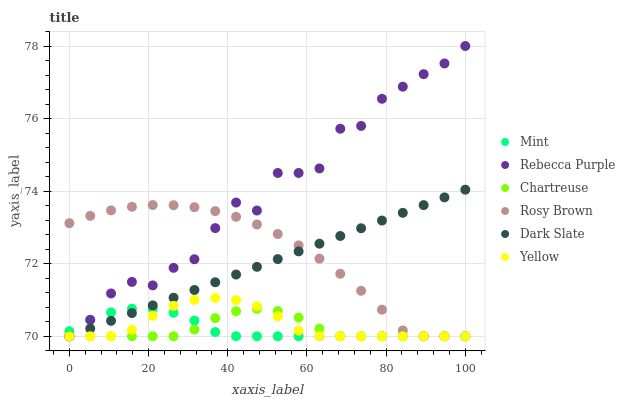Does Chartreuse have the minimum area under the curve?
Answer yes or no. Yes. Does Rebecca Purple have the maximum area under the curve?
Answer yes or no. Yes. Does Yellow have the minimum area under the curve?
Answer yes or no. No. Does Yellow have the maximum area under the curve?
Answer yes or no. No. Is Dark Slate the smoothest?
Answer yes or no. Yes. Is Rebecca Purple the roughest?
Answer yes or no. Yes. Is Yellow the smoothest?
Answer yes or no. No. Is Yellow the roughest?
Answer yes or no. No. Does Rosy Brown have the lowest value?
Answer yes or no. Yes. Does Rebecca Purple have the highest value?
Answer yes or no. Yes. Does Yellow have the highest value?
Answer yes or no. No. Does Yellow intersect Mint?
Answer yes or no. Yes. Is Yellow less than Mint?
Answer yes or no. No. Is Yellow greater than Mint?
Answer yes or no. No. 